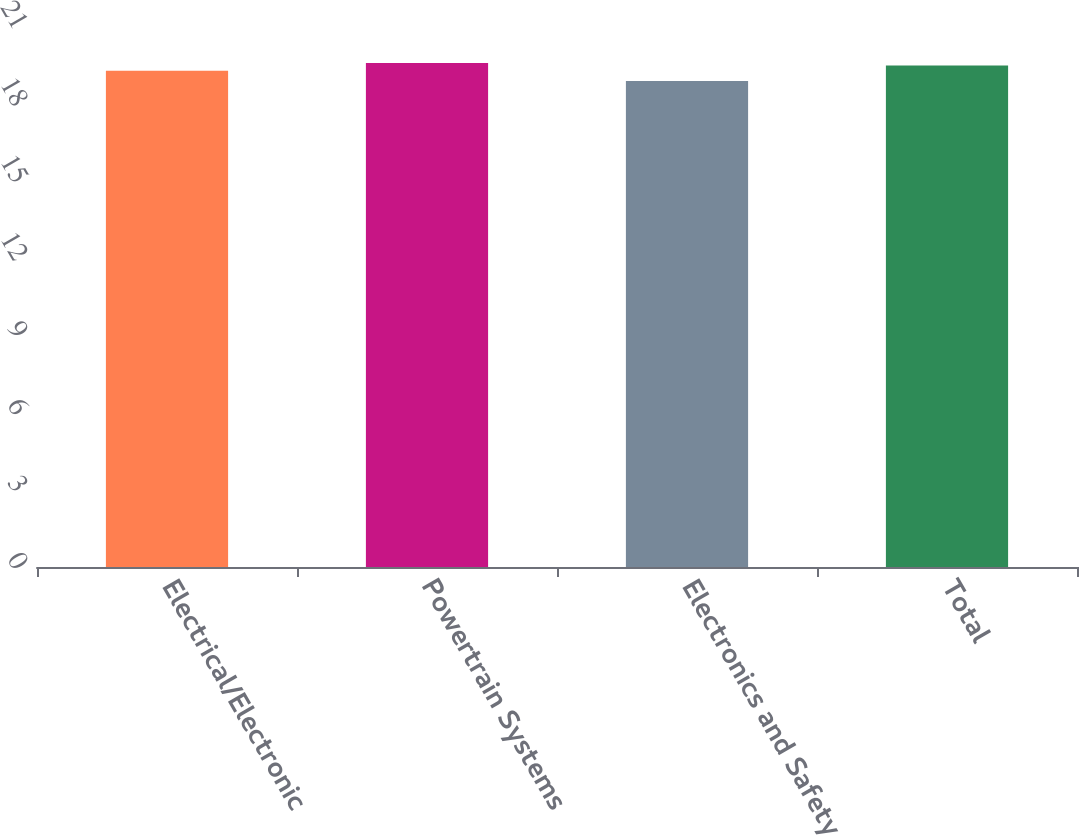Convert chart to OTSL. <chart><loc_0><loc_0><loc_500><loc_500><bar_chart><fcel>Electrical/Electronic<fcel>Powertrain Systems<fcel>Electronics and Safety<fcel>Total<nl><fcel>19.3<fcel>19.6<fcel>18.9<fcel>19.5<nl></chart> 